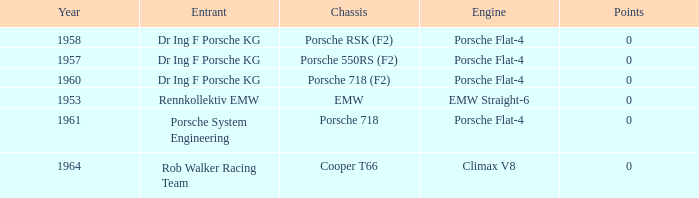Which year had more than 0 points? 0.0. 